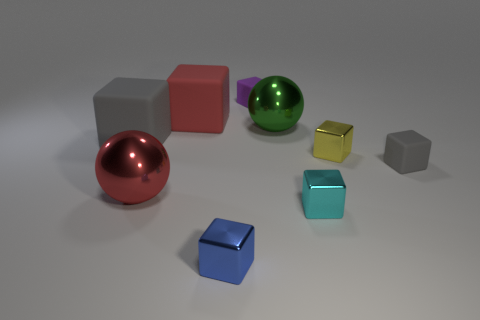Subtract 1 cubes. How many cubes are left? 6 Subtract all yellow blocks. How many blocks are left? 6 Subtract all tiny purple matte blocks. How many blocks are left? 6 Subtract all brown balls. Subtract all brown cylinders. How many balls are left? 2 Add 1 gray metal cylinders. How many objects exist? 10 Subtract all balls. How many objects are left? 7 Add 3 cyan blocks. How many cyan blocks exist? 4 Subtract 0 purple balls. How many objects are left? 9 Subtract all gray matte blocks. Subtract all tiny rubber blocks. How many objects are left? 5 Add 3 big green metallic things. How many big green metallic things are left? 4 